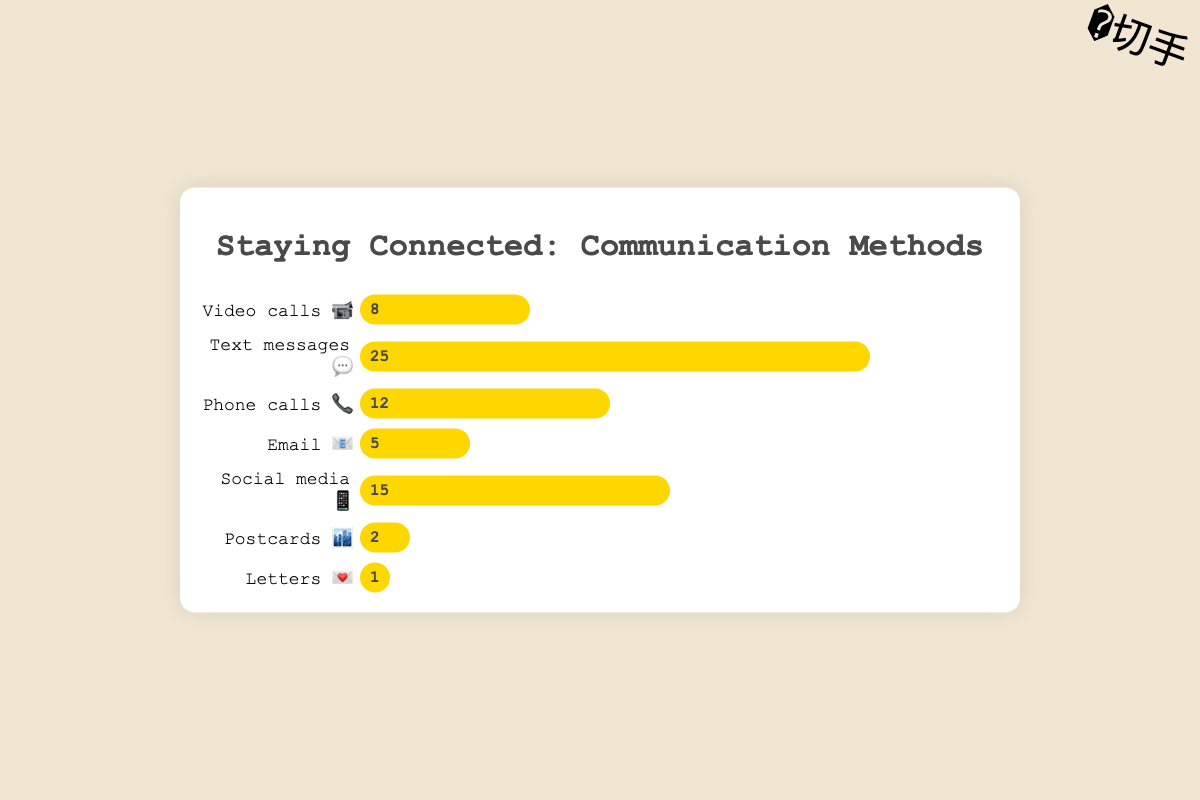What's the most frequently used method to stay in touch with family abroad? The highest frequency bar represents the most frequently used method. In this case, "Text messages 💬" has the highest frequency with 25.
Answer: Text messages 💬 Which communication method is used the least? The method with the smallest frequency bar indicates the least used method. Here, "Letters 💌" has the smallest frequency of 1.
Answer: Letters 💌 How many times are video calls 📹 used to stay in touch with family? Check the frequency bar for "Video calls 📹". It shows a frequency of 8.
Answer: 8 What is the sum of the frequencies for email 📧 and postcards 🏙️? Add the frequencies for "Email 📧" (5) and "Postcards 🏙️" (2). So, 5 + 2 = 7.
Answer: 7 Which is used more frequently: phone calls 📞 or social media 📱? Compare the frequencies of "Phone calls 📞" (12) and "Social media 📱" (15).
Answer: Social media 📱 What is the average frequency of all communication methods? Sum all frequencies: 8 + 25 + 12 + 5 + 15 + 2 + 1 = 68. There are 7 methods, so the average is 68 / 7 ≈ 9.71.
Answer: 9.71 Do text messages 💬 and social media 📱 combined account for more than 50% of the total communication frequency? Sum the frequencies of "Text messages 💬" (25) and "Social media 📱" (15). Total is 25 + 15 = 40. Sum of all methods' frequencies is 68. 40/68 > 0.5 or 50% is true.
Answer: Yes By how much does the frequency of phone calls 📞 exceed email 📧? Subtract the frequency of "Email 📧" (5) from "Phone calls 📞" (12). 12 - 5 = 7.
Answer: 7 What is the ratio of the frequency of video calls 📹 to letters 💌? The frequency of "Video calls 📹" is 8, and for "Letters 💌" it's 1. So, the ratio is 8:1.
Answer: 8:1 